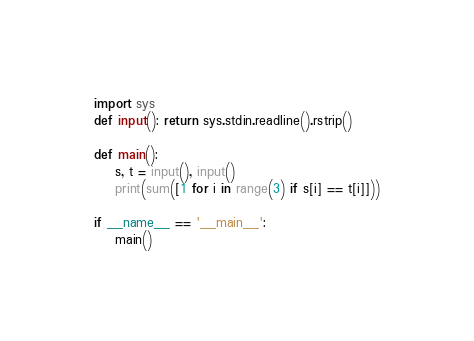<code> <loc_0><loc_0><loc_500><loc_500><_Python_>import sys
def input(): return sys.stdin.readline().rstrip()

def main():
    s, t = input(), input()
    print(sum([1 for i in range(3) if s[i] == t[i]]))

if __name__ == '__main__':
    main()
</code> 